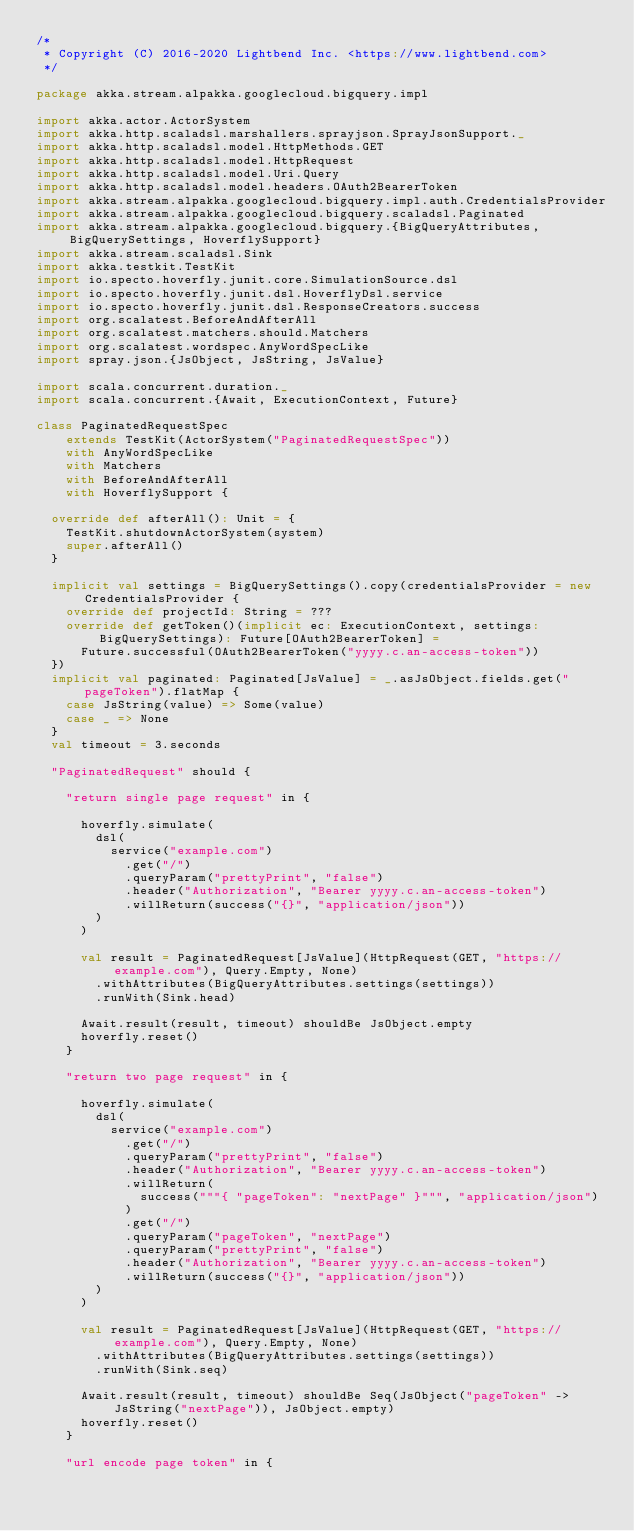<code> <loc_0><loc_0><loc_500><loc_500><_Scala_>/*
 * Copyright (C) 2016-2020 Lightbend Inc. <https://www.lightbend.com>
 */

package akka.stream.alpakka.googlecloud.bigquery.impl

import akka.actor.ActorSystem
import akka.http.scaladsl.marshallers.sprayjson.SprayJsonSupport._
import akka.http.scaladsl.model.HttpMethods.GET
import akka.http.scaladsl.model.HttpRequest
import akka.http.scaladsl.model.Uri.Query
import akka.http.scaladsl.model.headers.OAuth2BearerToken
import akka.stream.alpakka.googlecloud.bigquery.impl.auth.CredentialsProvider
import akka.stream.alpakka.googlecloud.bigquery.scaladsl.Paginated
import akka.stream.alpakka.googlecloud.bigquery.{BigQueryAttributes, BigQuerySettings, HoverflySupport}
import akka.stream.scaladsl.Sink
import akka.testkit.TestKit
import io.specto.hoverfly.junit.core.SimulationSource.dsl
import io.specto.hoverfly.junit.dsl.HoverflyDsl.service
import io.specto.hoverfly.junit.dsl.ResponseCreators.success
import org.scalatest.BeforeAndAfterAll
import org.scalatest.matchers.should.Matchers
import org.scalatest.wordspec.AnyWordSpecLike
import spray.json.{JsObject, JsString, JsValue}

import scala.concurrent.duration._
import scala.concurrent.{Await, ExecutionContext, Future}

class PaginatedRequestSpec
    extends TestKit(ActorSystem("PaginatedRequestSpec"))
    with AnyWordSpecLike
    with Matchers
    with BeforeAndAfterAll
    with HoverflySupport {

  override def afterAll(): Unit = {
    TestKit.shutdownActorSystem(system)
    super.afterAll()
  }

  implicit val settings = BigQuerySettings().copy(credentialsProvider = new CredentialsProvider {
    override def projectId: String = ???
    override def getToken()(implicit ec: ExecutionContext, settings: BigQuerySettings): Future[OAuth2BearerToken] =
      Future.successful(OAuth2BearerToken("yyyy.c.an-access-token"))
  })
  implicit val paginated: Paginated[JsValue] = _.asJsObject.fields.get("pageToken").flatMap {
    case JsString(value) => Some(value)
    case _ => None
  }
  val timeout = 3.seconds

  "PaginatedRequest" should {

    "return single page request" in {

      hoverfly.simulate(
        dsl(
          service("example.com")
            .get("/")
            .queryParam("prettyPrint", "false")
            .header("Authorization", "Bearer yyyy.c.an-access-token")
            .willReturn(success("{}", "application/json"))
        )
      )

      val result = PaginatedRequest[JsValue](HttpRequest(GET, "https://example.com"), Query.Empty, None)
        .withAttributes(BigQueryAttributes.settings(settings))
        .runWith(Sink.head)

      Await.result(result, timeout) shouldBe JsObject.empty
      hoverfly.reset()
    }

    "return two page request" in {

      hoverfly.simulate(
        dsl(
          service("example.com")
            .get("/")
            .queryParam("prettyPrint", "false")
            .header("Authorization", "Bearer yyyy.c.an-access-token")
            .willReturn(
              success("""{ "pageToken": "nextPage" }""", "application/json")
            )
            .get("/")
            .queryParam("pageToken", "nextPage")
            .queryParam("prettyPrint", "false")
            .header("Authorization", "Bearer yyyy.c.an-access-token")
            .willReturn(success("{}", "application/json"))
        )
      )

      val result = PaginatedRequest[JsValue](HttpRequest(GET, "https://example.com"), Query.Empty, None)
        .withAttributes(BigQueryAttributes.settings(settings))
        .runWith(Sink.seq)

      Await.result(result, timeout) shouldBe Seq(JsObject("pageToken" -> JsString("nextPage")), JsObject.empty)
      hoverfly.reset()
    }

    "url encode page token" in {
</code> 